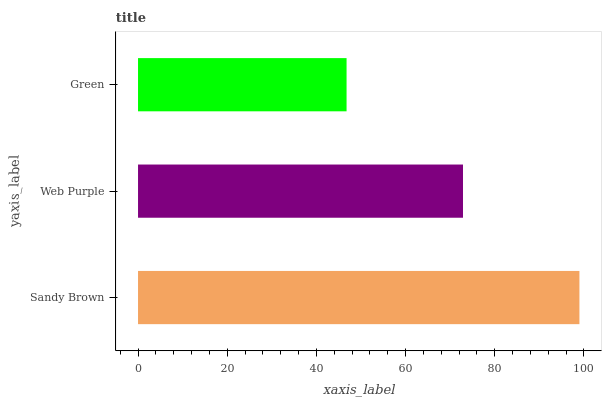Is Green the minimum?
Answer yes or no. Yes. Is Sandy Brown the maximum?
Answer yes or no. Yes. Is Web Purple the minimum?
Answer yes or no. No. Is Web Purple the maximum?
Answer yes or no. No. Is Sandy Brown greater than Web Purple?
Answer yes or no. Yes. Is Web Purple less than Sandy Brown?
Answer yes or no. Yes. Is Web Purple greater than Sandy Brown?
Answer yes or no. No. Is Sandy Brown less than Web Purple?
Answer yes or no. No. Is Web Purple the high median?
Answer yes or no. Yes. Is Web Purple the low median?
Answer yes or no. Yes. Is Green the high median?
Answer yes or no. No. Is Green the low median?
Answer yes or no. No. 